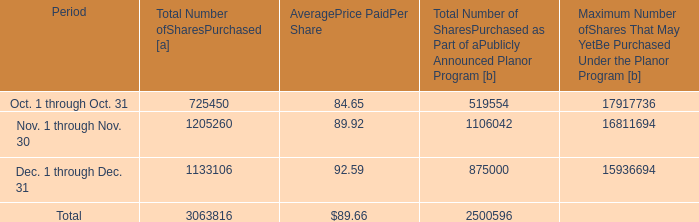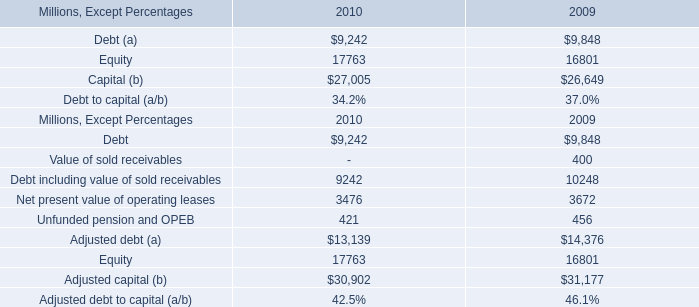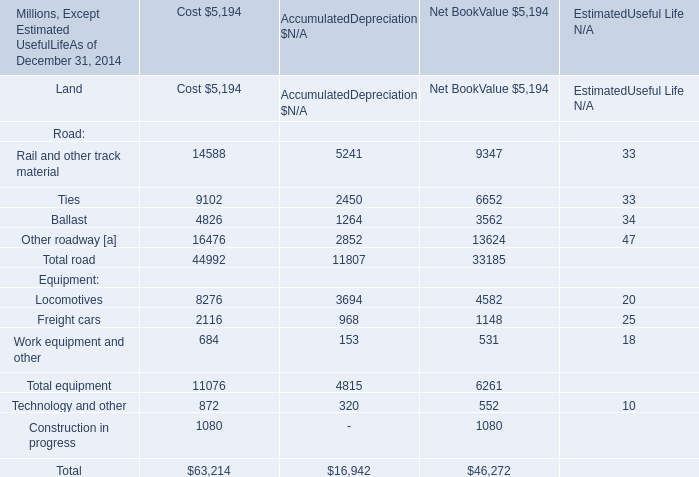What was the Net Book Value for Total equipment as of December 31,2014? (in million) 
Answer: 6261. 